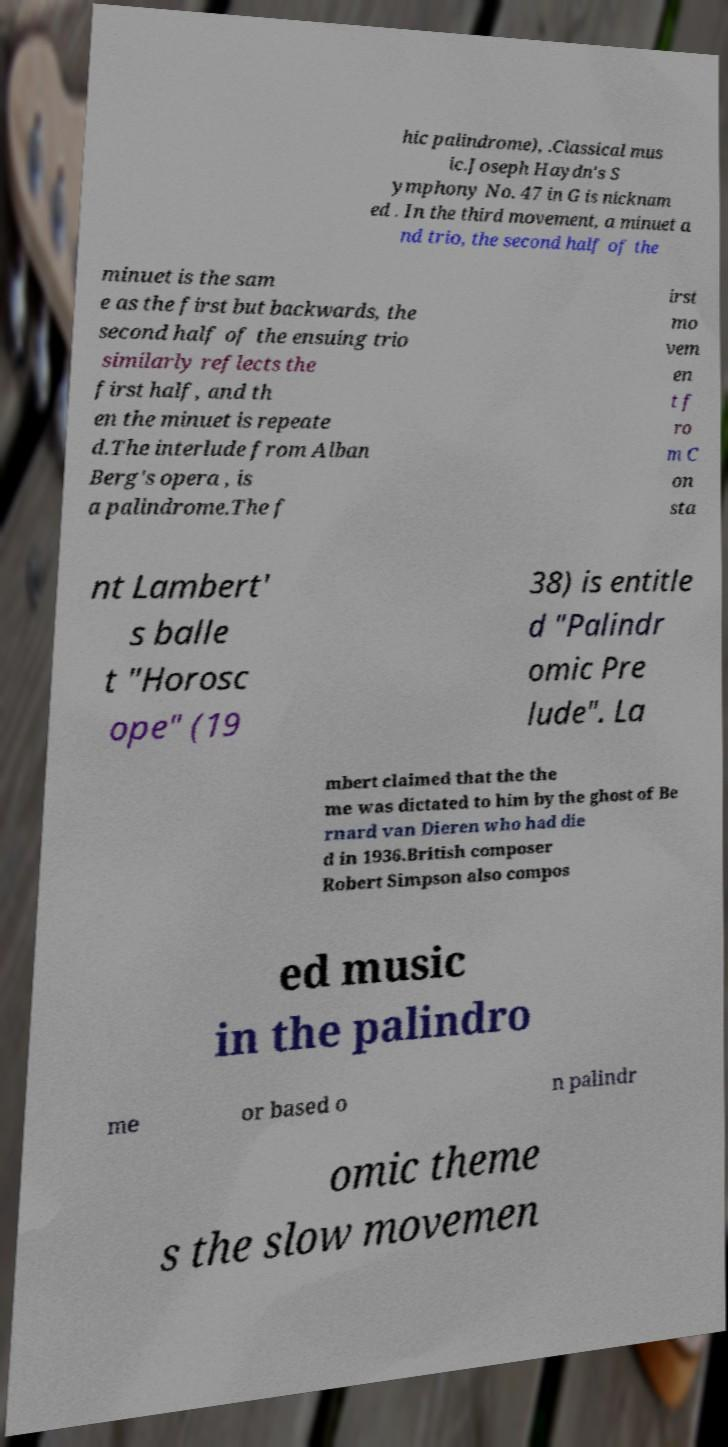Could you extract and type out the text from this image? hic palindrome), .Classical mus ic.Joseph Haydn's S ymphony No. 47 in G is nicknam ed . In the third movement, a minuet a nd trio, the second half of the minuet is the sam e as the first but backwards, the second half of the ensuing trio similarly reflects the first half, and th en the minuet is repeate d.The interlude from Alban Berg's opera , is a palindrome.The f irst mo vem en t f ro m C on sta nt Lambert' s balle t "Horosc ope" (19 38) is entitle d "Palindr omic Pre lude". La mbert claimed that the the me was dictated to him by the ghost of Be rnard van Dieren who had die d in 1936.British composer Robert Simpson also compos ed music in the palindro me or based o n palindr omic theme s the slow movemen 